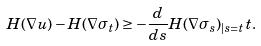<formula> <loc_0><loc_0><loc_500><loc_500>H ( \nabla u ) - H ( \nabla \sigma _ { t } ) \geq - \frac { d } { d s } H ( \nabla \sigma _ { s } ) _ { | s = t } \, t .</formula> 